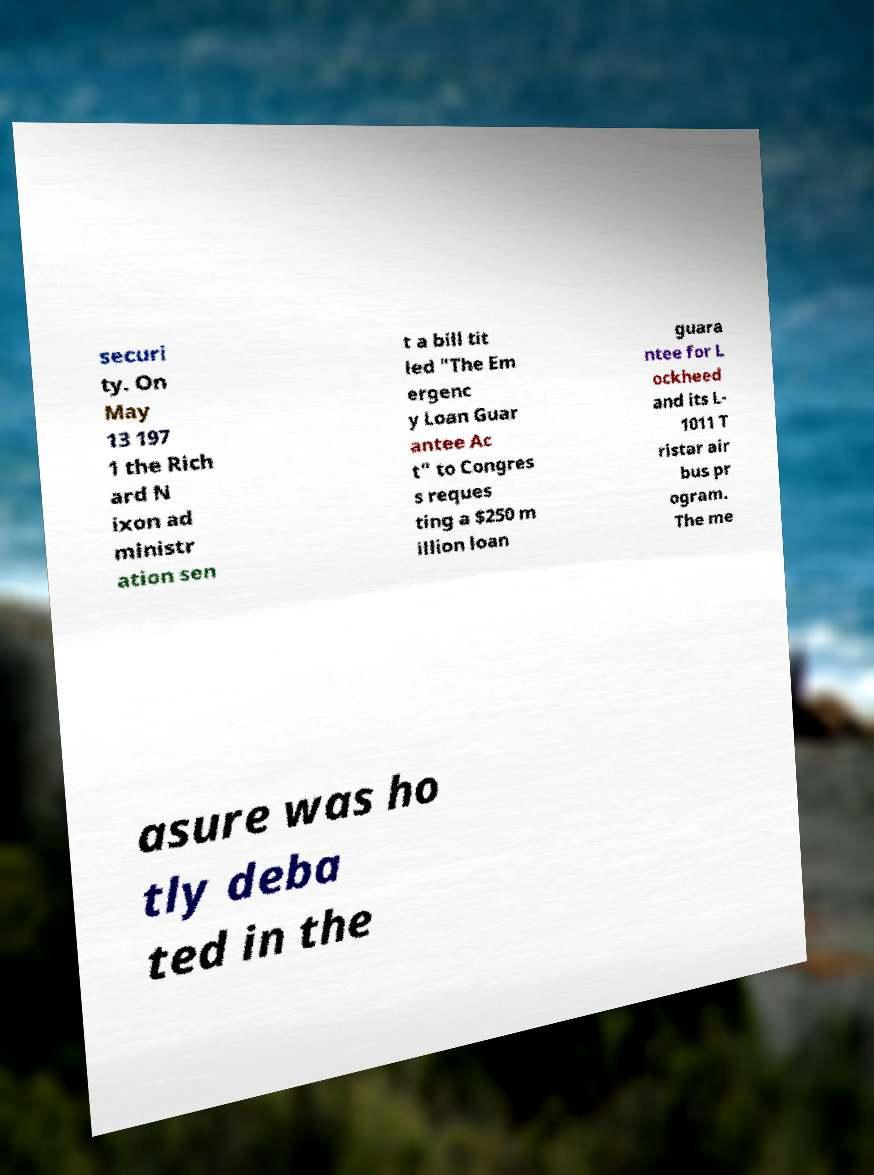Please identify and transcribe the text found in this image. securi ty. On May 13 197 1 the Rich ard N ixon ad ministr ation sen t a bill tit led "The Em ergenc y Loan Guar antee Ac t" to Congres s reques ting a $250 m illion loan guara ntee for L ockheed and its L- 1011 T ristar air bus pr ogram. The me asure was ho tly deba ted in the 